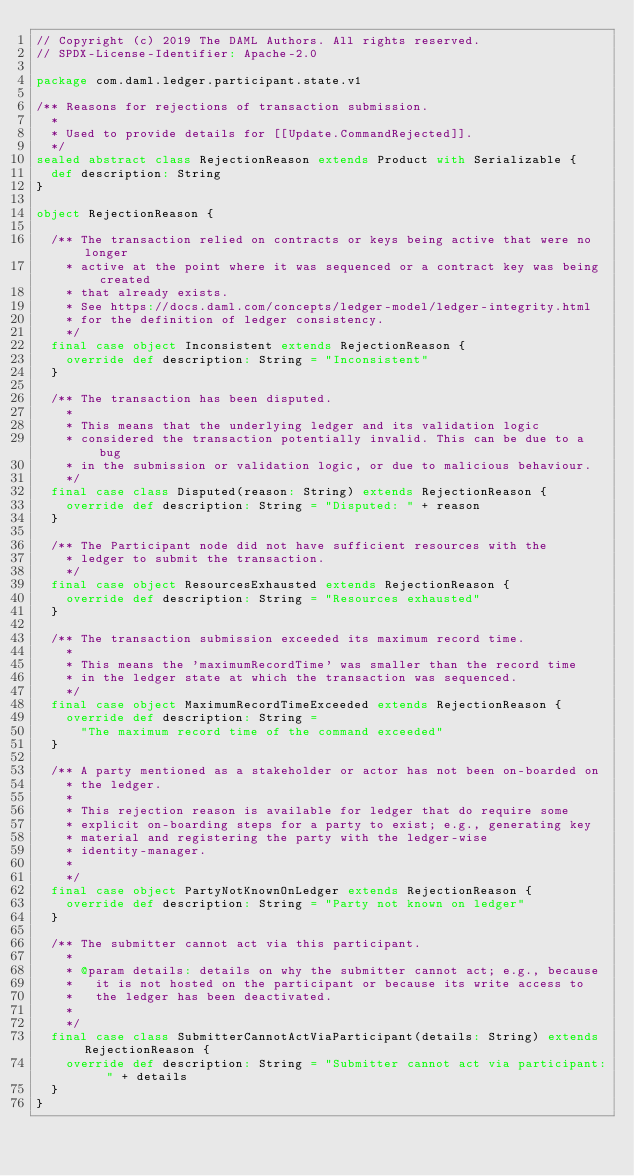<code> <loc_0><loc_0><loc_500><loc_500><_Scala_>// Copyright (c) 2019 The DAML Authors. All rights reserved.
// SPDX-License-Identifier: Apache-2.0

package com.daml.ledger.participant.state.v1

/** Reasons for rejections of transaction submission.
  *
  * Used to provide details for [[Update.CommandRejected]].
  */
sealed abstract class RejectionReason extends Product with Serializable {
  def description: String
}

object RejectionReason {

  /** The transaction relied on contracts or keys being active that were no longer
    * active at the point where it was sequenced or a contract key was being created
    * that already exists.
    * See https://docs.daml.com/concepts/ledger-model/ledger-integrity.html
    * for the definition of ledger consistency.
    */
  final case object Inconsistent extends RejectionReason {
    override def description: String = "Inconsistent"
  }

  /** The transaction has been disputed.
    *
    * This means that the underlying ledger and its validation logic
    * considered the transaction potentially invalid. This can be due to a bug
    * in the submission or validation logic, or due to malicious behaviour.
    */
  final case class Disputed(reason: String) extends RejectionReason {
    override def description: String = "Disputed: " + reason
  }

  /** The Participant node did not have sufficient resources with the
    * ledger to submit the transaction.
    */
  final case object ResourcesExhausted extends RejectionReason {
    override def description: String = "Resources exhausted"
  }

  /** The transaction submission exceeded its maximum record time.
    *
    * This means the 'maximumRecordTime' was smaller than the record time
    * in the ledger state at which the transaction was sequenced.
    */
  final case object MaximumRecordTimeExceeded extends RejectionReason {
    override def description: String =
      "The maximum record time of the command exceeded"
  }

  /** A party mentioned as a stakeholder or actor has not been on-boarded on
    * the ledger.
    *
    * This rejection reason is available for ledger that do require some
    * explicit on-boarding steps for a party to exist; e.g., generating key
    * material and registering the party with the ledger-wise
    * identity-manager.
    *
    */
  final case object PartyNotKnownOnLedger extends RejectionReason {
    override def description: String = "Party not known on ledger"
  }

  /** The submitter cannot act via this participant.
    *
    * @param details: details on why the submitter cannot act; e.g., because
    *   it is not hosted on the participant or because its write access to
    *   the ledger has been deactivated.
    *
    */
  final case class SubmitterCannotActViaParticipant(details: String) extends RejectionReason {
    override def description: String = "Submitter cannot act via participant: " + details
  }
}
</code> 